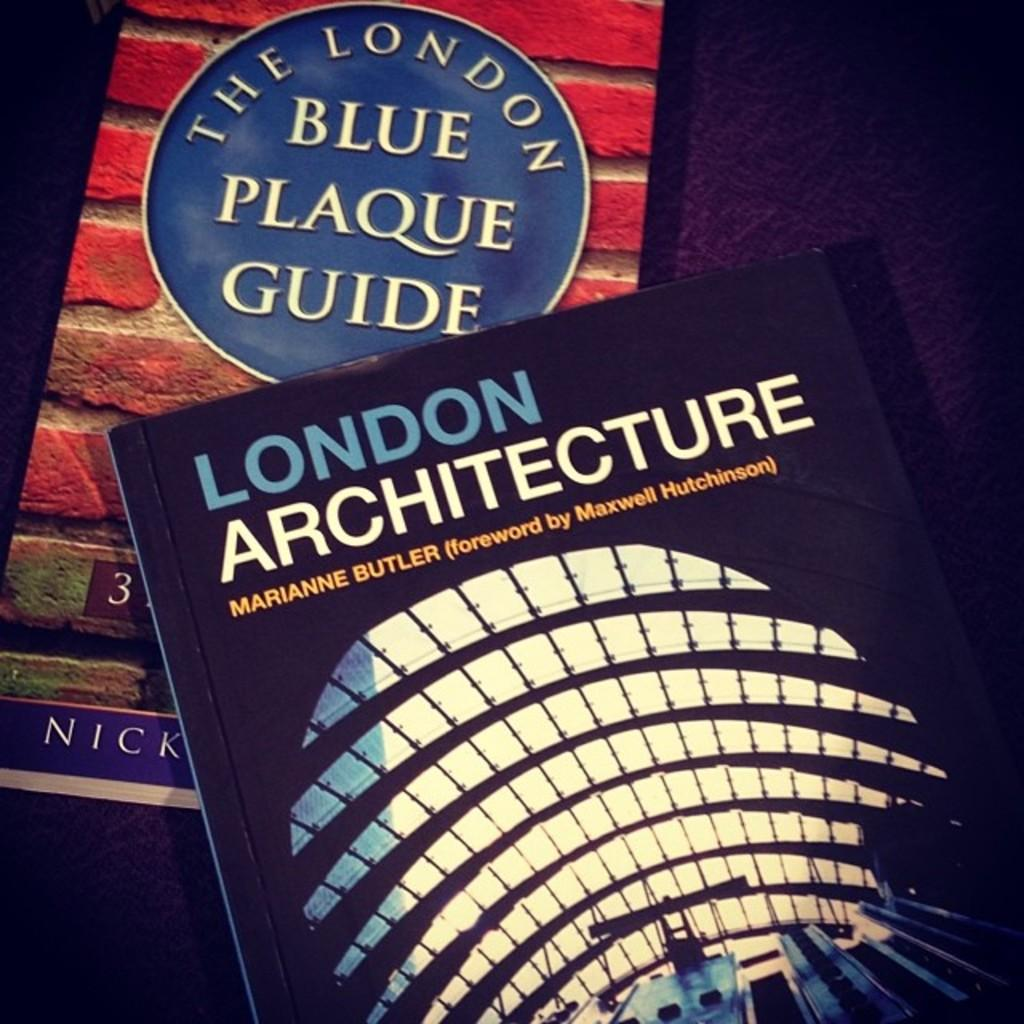Provide a one-sentence caption for the provided image. Two books with the one on top being for London architecture. 